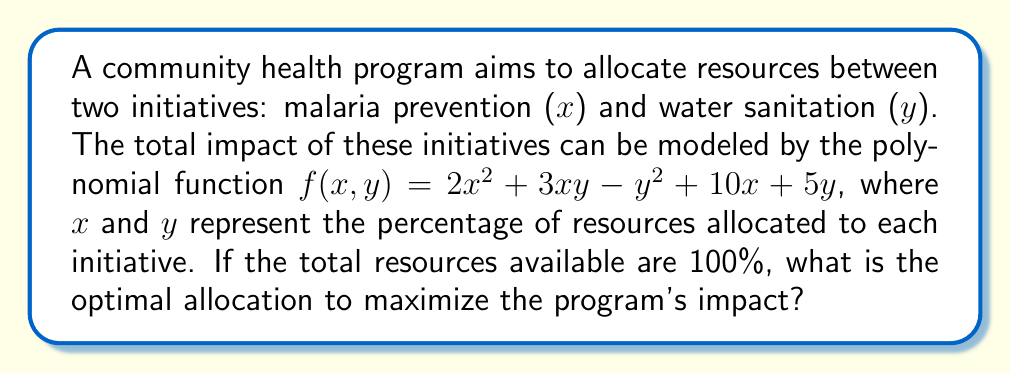Could you help me with this problem? To find the optimal allocation, we need to maximize the function $f(x,y)$ subject to the constraint $x + y = 1$ (or 100%).

1. Use the method of Lagrange multipliers. Let $\lambda$ be the Lagrange multiplier.
   $L(x,y,\lambda) = 2x^2 + 3xy - y^2 + 10x + 5y + \lambda(1-x-y)$

2. Find partial derivatives and set them to zero:
   $\frac{\partial L}{\partial x} = 4x + 3y + 10 - \lambda = 0$
   $\frac{\partial L}{\partial y} = 3x - 2y + 5 - \lambda = 0$
   $\frac{\partial L}{\partial \lambda} = 1 - x - y = 0$

3. From the last equation: $y = 1 - x$

4. Substitute this into the first two equations:
   $4x + 3(1-x) + 10 - \lambda = 0$
   $3x - 2(1-x) + 5 - \lambda = 0$

5. Simplify:
   $x + 13 - \lambda = 0$
   $5x + 3 - \lambda = 0$

6. Equate these:
   $x + 13 = 5x + 3$
   $10 = 4x$
   $x = \frac{5}{2} = 2.5$

7. Since $x = 2.5$ is outside our constraint (0% to 100%), we need to check the endpoints.

8. When $x = 0$, $y = 1$: $f(0,1) = -1 + 5 = 4$
   When $x = 1$, $y = 0$: $f(1,0) = 2 + 10 = 12$

Therefore, the optimal allocation is $x = 1$ (100% to malaria prevention) and $y = 0$ (0% to water sanitation).
Answer: 100% to malaria prevention, 0% to water sanitation 